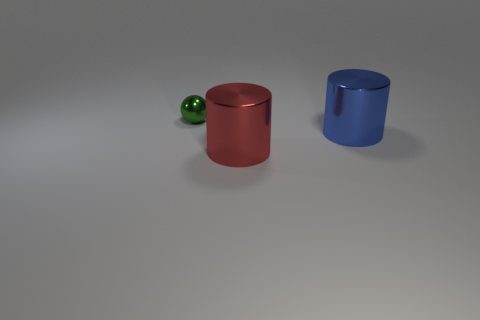Add 1 red shiny things. How many objects exist? 4 Subtract all cylinders. How many objects are left? 1 Subtract 0 brown cylinders. How many objects are left? 3 Subtract all blue rubber blocks. Subtract all tiny green shiny spheres. How many objects are left? 2 Add 3 spheres. How many spheres are left? 4 Add 3 green things. How many green things exist? 4 